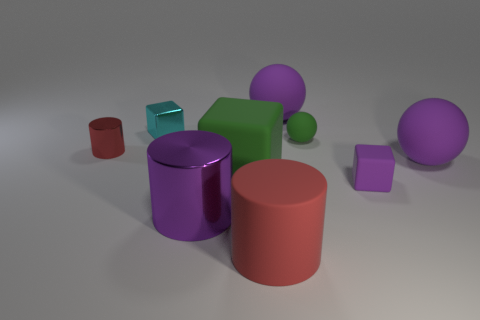What number of other objects are the same size as the purple cylinder?
Offer a very short reply. 4. There is a purple object that is on the left side of the rubber cylinder; is its shape the same as the tiny object that is left of the small cyan shiny object?
Keep it short and to the point. Yes. How many matte cylinders are on the right side of the tiny red cylinder?
Offer a very short reply. 1. The metal cylinder that is behind the big green thing is what color?
Your answer should be compact. Red. What color is the large thing that is the same shape as the tiny purple object?
Give a very brief answer. Green. Is there anything else that has the same color as the small sphere?
Give a very brief answer. Yes. Is the number of large green cylinders greater than the number of small matte objects?
Ensure brevity in your answer.  No. Does the green block have the same material as the tiny cyan thing?
Your answer should be compact. No. How many other big green cubes are the same material as the large green cube?
Give a very brief answer. 0. Do the purple cylinder and the red cylinder that is behind the big rubber cube have the same size?
Your answer should be very brief. No. 